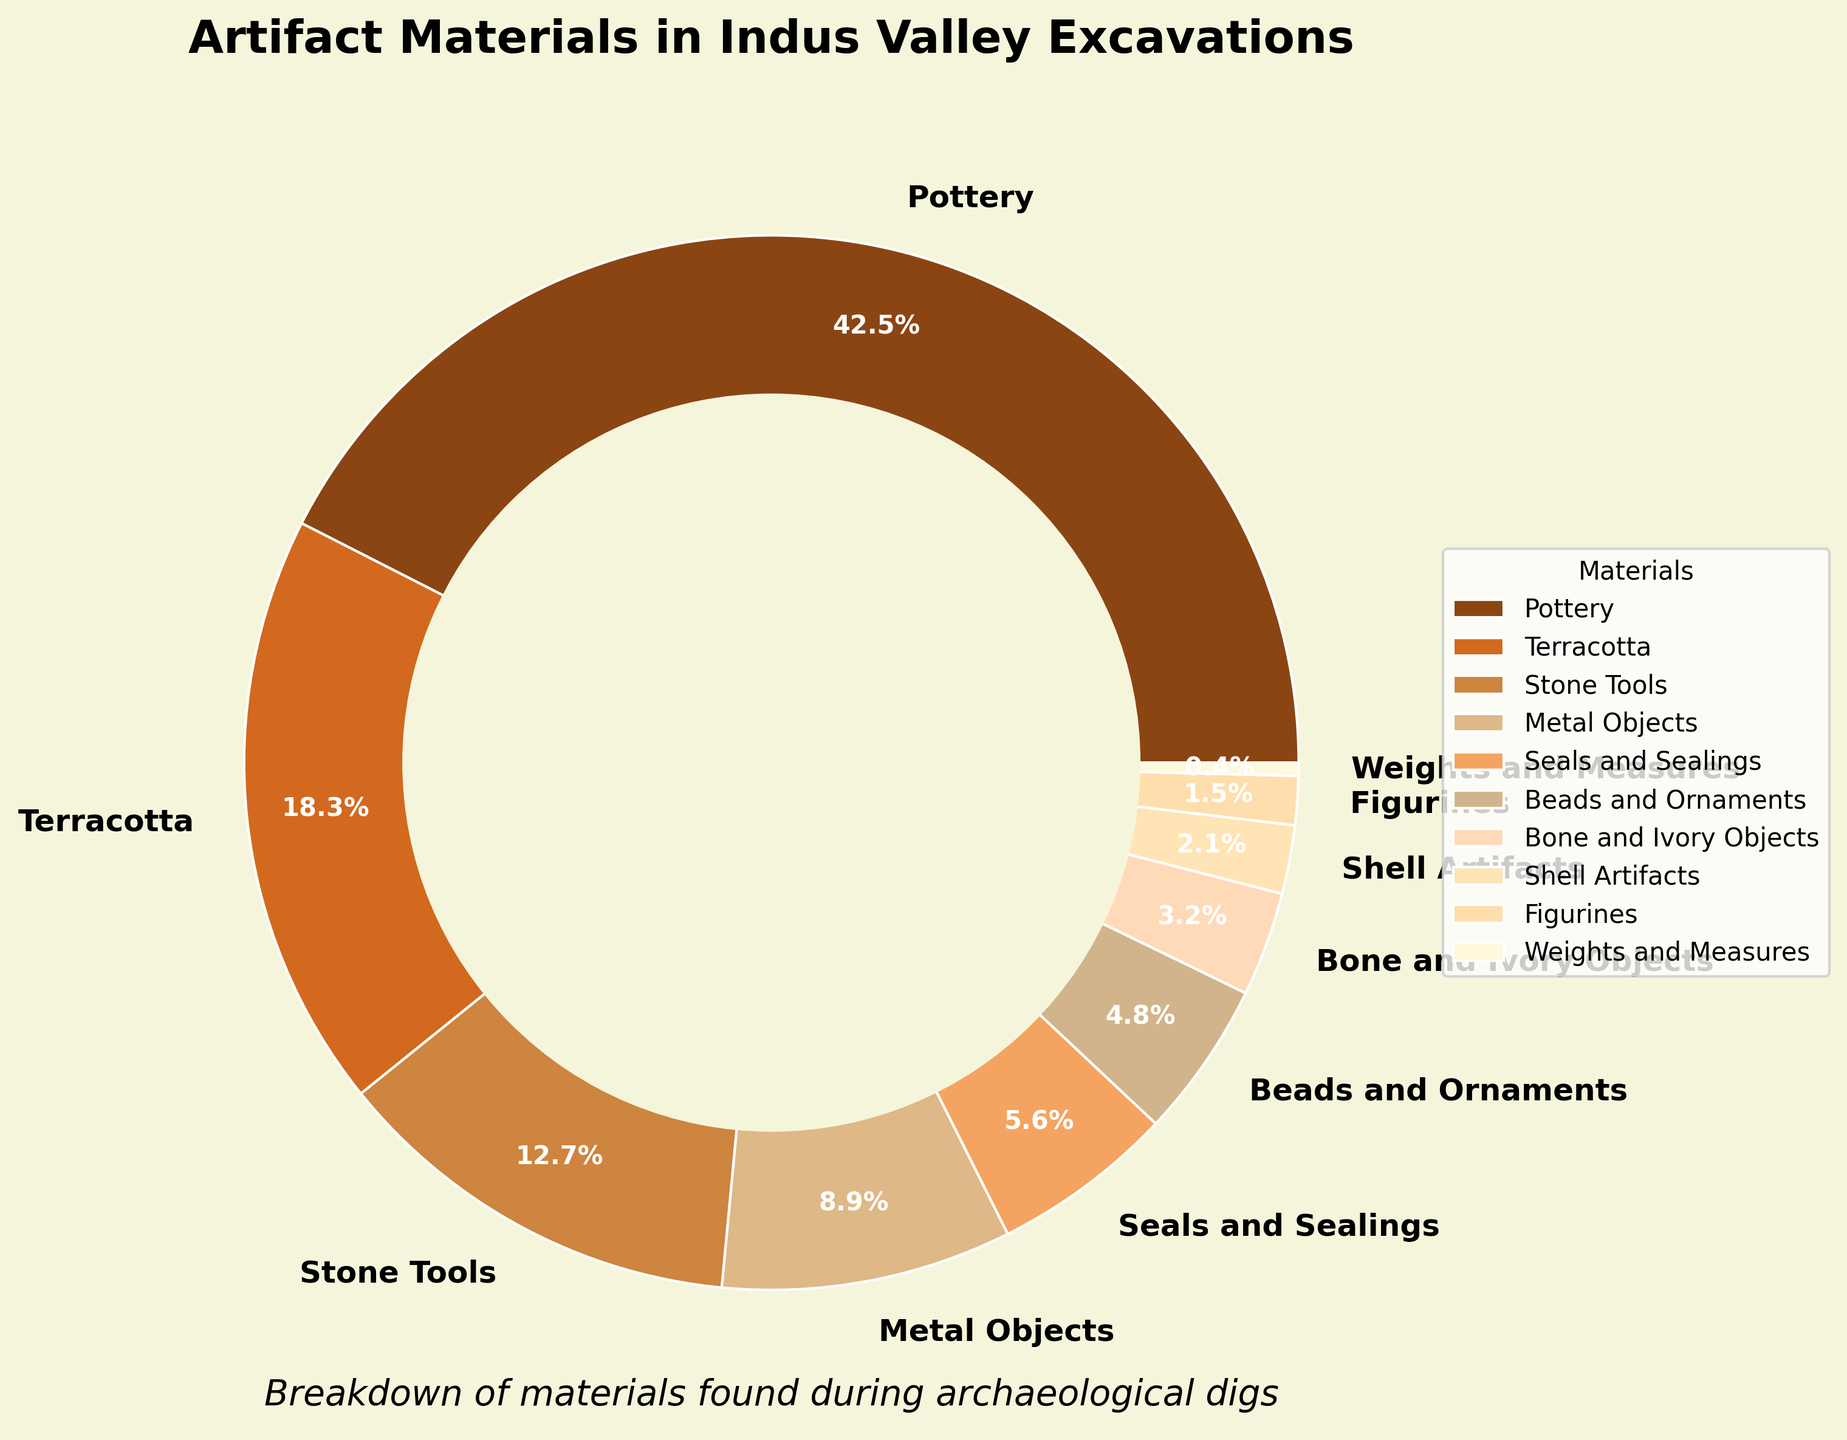What's the most common material found in the Indus Valley excavations? The pie chart shows various materials with their respective percentages. Pottery has the largest percentage at 42.5%.
Answer: Pottery Which material category has the least presence in the findings? The pie chart shows "Weights and Measures" with the smallest slice and a percentage of 0.4%.
Answer: Weights and Measures How much more common are stone tools compared to figurines? The pie chart shows stone tools at 12.7% and figurines at 1.5%. Subtracting the percentage of figurines from the percentage of stone tools gives 12.7% - 1.5% = 11.2%.
Answer: 11.2% If you combine terracotta and stone tools, does their percentage exceed that of pottery? By how much? The chart shows terracotta at 18.3% and stone tools at 12.7%. Adding them together gives 18.3% + 12.7% = 31%. Since pottery is 42.5%, the combined percentage of terracotta and stone tools does not exceed pottery.
Answer: No, 0% Which material is more prevalent: metal objects or beads and ornaments? The pie chart indicates metal objects at 8.9% and beads and ornaments at 4.8%. Metal objects have a higher percentage.
Answer: Metal objects By what factor is the presence of pottery greater than that of bone and ivory objects? Pottery is at 42.5% and bone and ivory objects are at 3.2%. Dividing 42.5 by 3.2 gives approximately 13.3.
Answer: 13.3 Does the percentage of seals and sealings plus shell artifacts add up to more than 10%? Seals and sealings are at 5.6% and shell artifacts are at 2.1%. Adding them gives 5.6% + 2.1% = 7.7%, which is less than 10%.
Answer: No, 7.7% Which material's percentage is closest to 5%? The chart indicates that seals and sealings have a percentage of 5.6%, which is the closest to 5%.
Answer: Seals and Sealings What is the total percentage of the top three most prevalent artifact materials? The top three materials are pottery (42.5%), terracotta (18.3%), and stone tools (12.7%). Adding them gives 42.5% + 18.3% + 12.7% = 73.5%.
Answer: 73.5% 